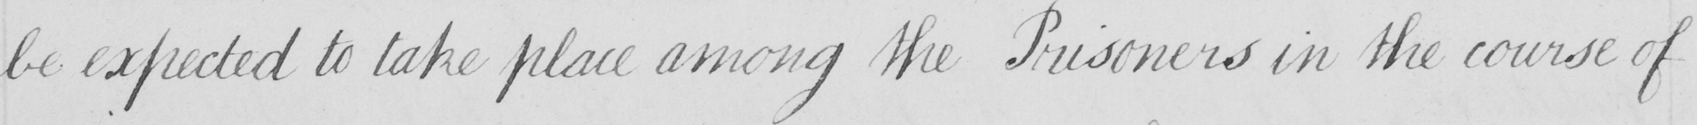What is written in this line of handwriting? be expected to take place among the Prisoners in the course of 